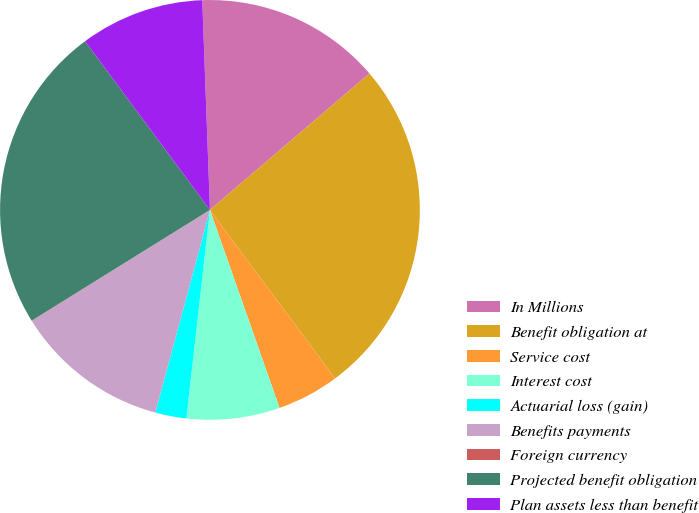Convert chart. <chart><loc_0><loc_0><loc_500><loc_500><pie_chart><fcel>In Millions<fcel>Benefit obligation at<fcel>Service cost<fcel>Interest cost<fcel>Actuarial loss (gain)<fcel>Benefits payments<fcel>Foreign currency<fcel>Projected benefit obligation<fcel>Plan assets less than benefit<nl><fcel>14.32%<fcel>26.09%<fcel>4.79%<fcel>7.17%<fcel>2.4%<fcel>11.94%<fcel>0.02%<fcel>23.7%<fcel>9.56%<nl></chart> 